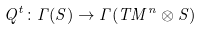<formula> <loc_0><loc_0><loc_500><loc_500>Q ^ { t } \colon \Gamma ( S ) \to \Gamma ( T M ^ { n } \otimes S )</formula> 